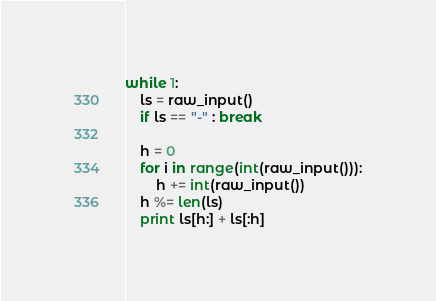<code> <loc_0><loc_0><loc_500><loc_500><_Python_>while 1:
	ls = raw_input()
	if ls == "-" : break
	
	h = 0
	for i in range(int(raw_input())):
		h += int(raw_input())
	h %= len(ls)
	print ls[h:] + ls[:h]</code> 